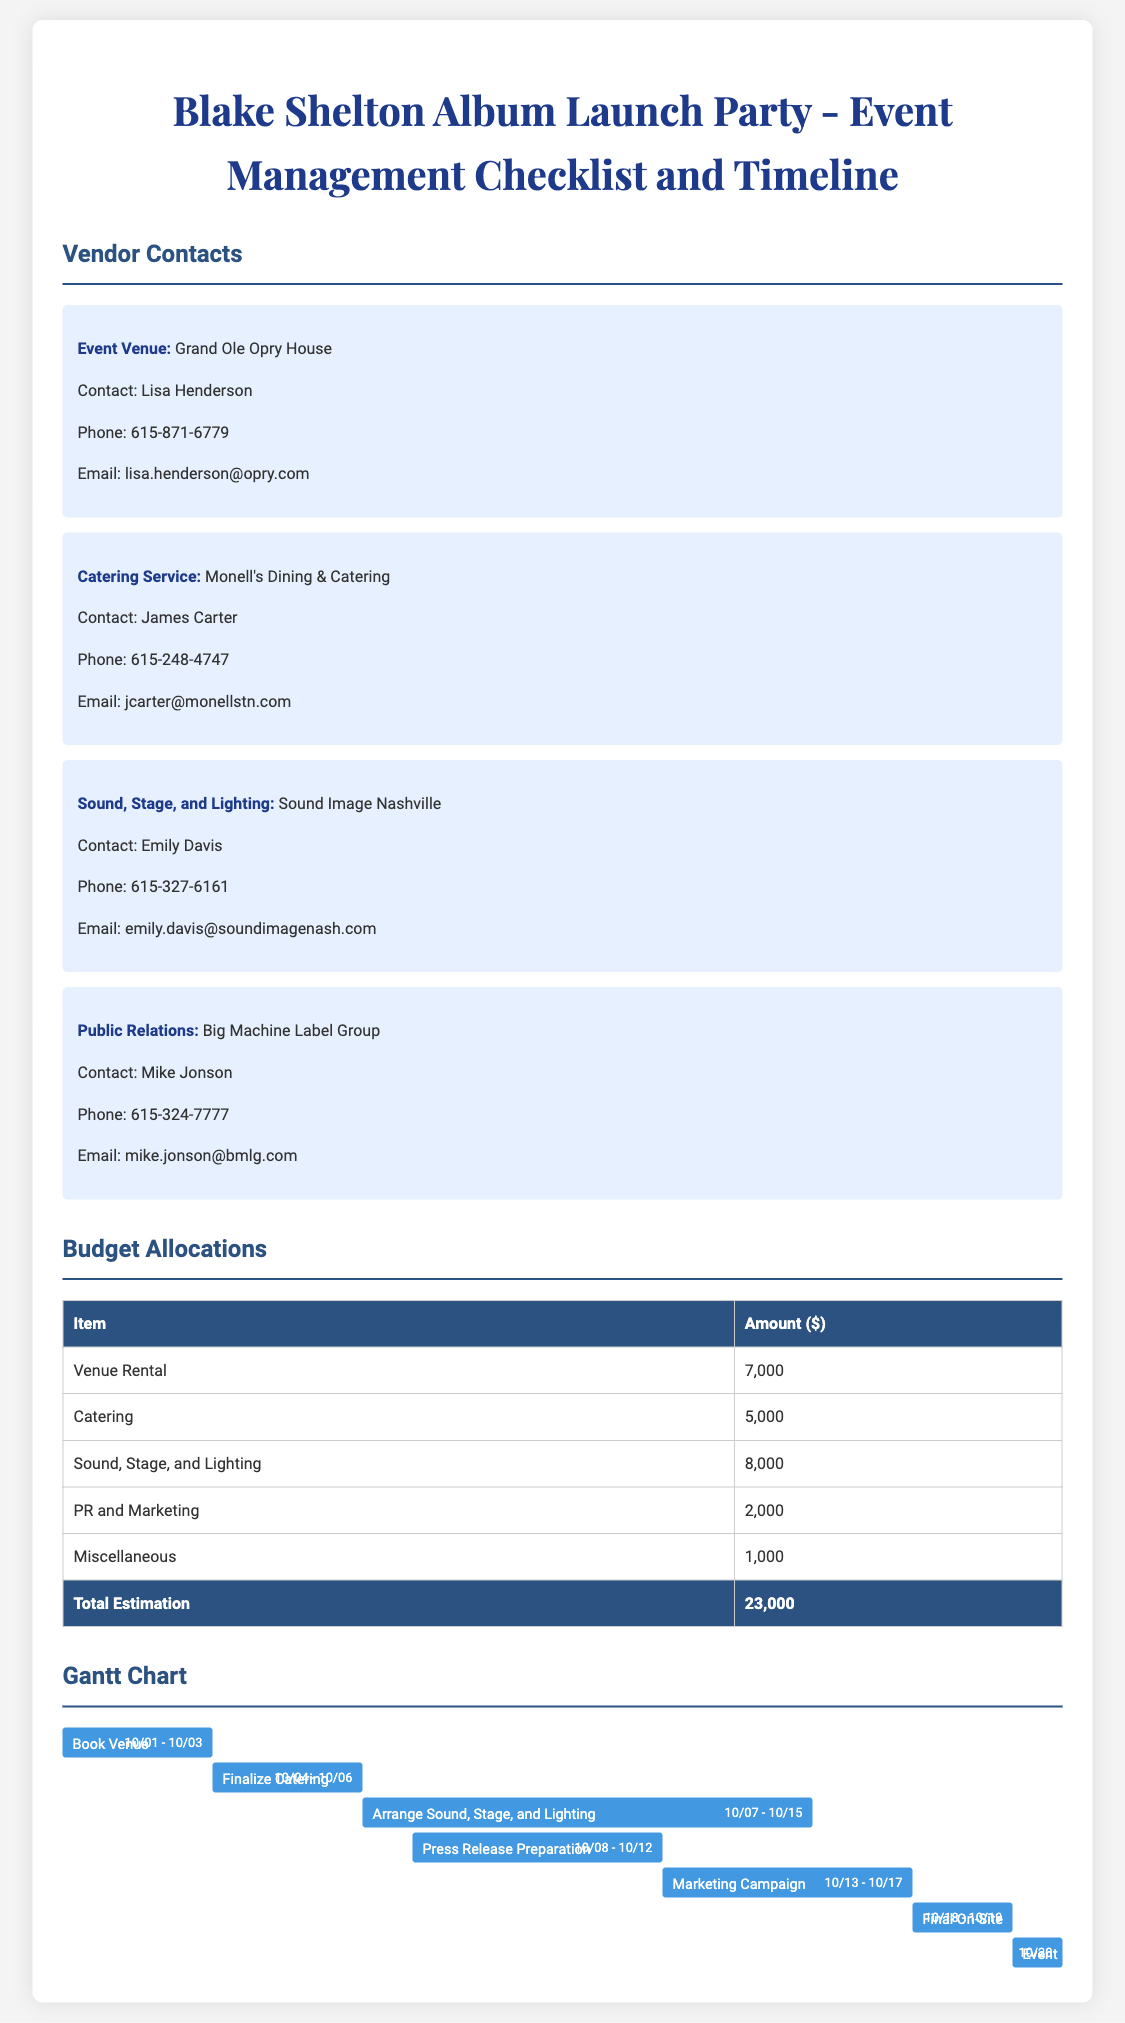What is the venue for the launch party? The document specifically mentions the Grand Ole Opry House as the venue for the event.
Answer: Grand Ole Opry House Who is the contact person for catering? The document lists James Carter as the contact for Monell's Dining & Catering.
Answer: James Carter How much is allocated for the marketing campaign? The budget table indicates that $2,000 is allocated for PR and Marketing.
Answer: 2,000 What are the dates for the final on-site checks? The Gantt chart specifies the final on-site checks are scheduled from 10/18 to 10/19.
Answer: 10/18 - 10/19 What is the total estimated budget for the event? The document sums up the budget allocations to provide a total estimation of the expenses.
Answer: 23,000 Which task has the longest scheduled period? The Gantt chart shows that arranging sound, stage, and lighting takes the longest, from 10/07 to 10/15.
Answer: Arrange Sound, Stage, and Lighting What is the primary color used in the headings? The document consistently uses a specific color for all headings, which in this case is a shade of blue.
Answer: #2c5282 Who is the vendor for sound, stage, and lighting? The document identifies Sound Image Nashville as the vendor for this service.
Answer: Sound Image Nashville What is the date of the event? According to the Gantt chart, the event day is scheduled for October 20.
Answer: 10/20 